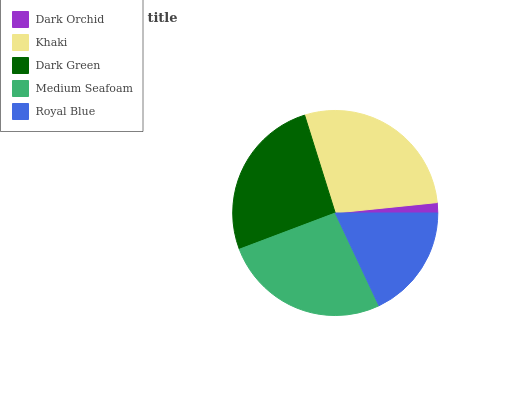Is Dark Orchid the minimum?
Answer yes or no. Yes. Is Khaki the maximum?
Answer yes or no. Yes. Is Dark Green the minimum?
Answer yes or no. No. Is Dark Green the maximum?
Answer yes or no. No. Is Khaki greater than Dark Green?
Answer yes or no. Yes. Is Dark Green less than Khaki?
Answer yes or no. Yes. Is Dark Green greater than Khaki?
Answer yes or no. No. Is Khaki less than Dark Green?
Answer yes or no. No. Is Dark Green the high median?
Answer yes or no. Yes. Is Dark Green the low median?
Answer yes or no. Yes. Is Royal Blue the high median?
Answer yes or no. No. Is Royal Blue the low median?
Answer yes or no. No. 